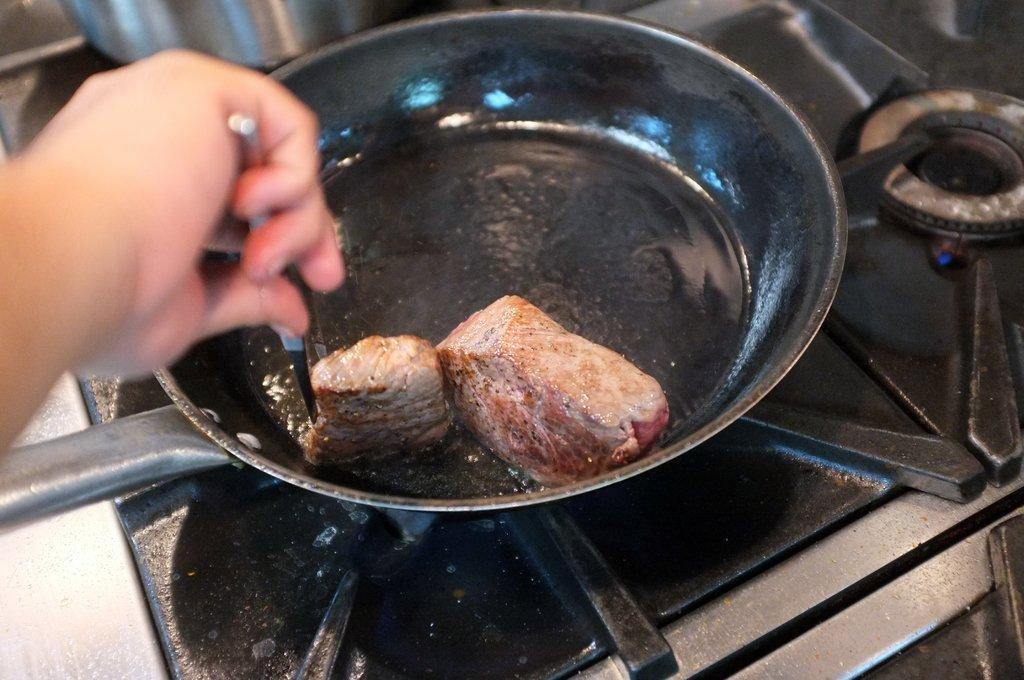What part of a person can be seen in the image? There is a person's hand in the image. What is the person holding in the image? The person is holding an object. What type of appliance is present in the image? There is a stove in the image. What tools are visible in the image? There are utensils in the image. What is being cooked in the image? There is a pan with a food product in the image. What type of quiver is visible in the image? There is no quiver present in the image. What kind of fish can be seen swimming in the pan? There is no fish present in the image; it features a pan with a food product. 